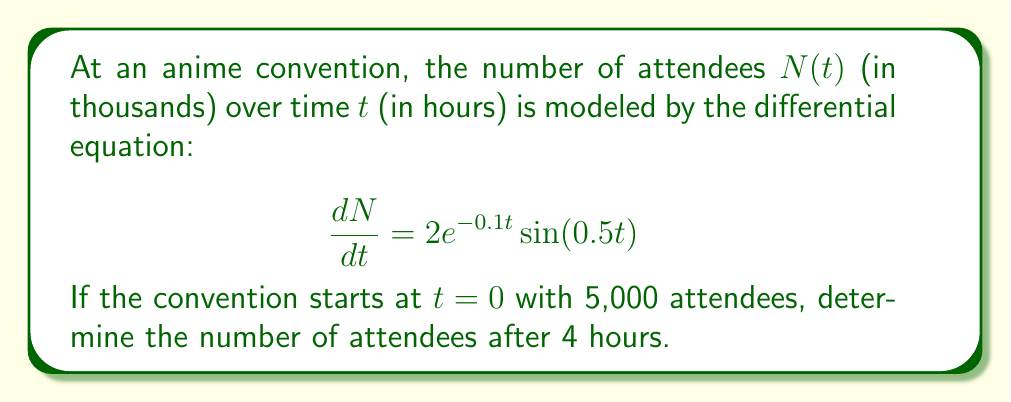Give your solution to this math problem. Let's approach this step-by-step:

1) We're given the differential equation:

   $$\frac{dN}{dt} = 2e^{-0.1t} \sin(0.5t)$$

2) To find the number of attendees at $t=4$, we need to integrate this equation from $t=0$ to $t=4$:

   $$N(4) - N(0) = \int_0^4 2e^{-0.1t} \sin(0.5t) dt$$

3) This integral doesn't have an elementary antiderivative, so we'll need to use numerical integration. We can use the trapezoidal rule with a small step size (let's use 0.1) for a good approximation.

4) Implementing the trapezoidal rule:

   $$\int_0^4 2e^{-0.1t} \sin(0.5t) dt \approx 0.1 \sum_{i=0}^{39} \frac{f(t_i) + f(t_{i+1})}{2}$$

   where $f(t) = 2e^{-0.1t} \sin(0.5t)$ and $t_i = 0.1i$

5) Calculating this sum (which can be done with a calculator or computer):

   $$\int_0^4 2e^{-0.1t} \sin(0.5t) dt \approx 2.7136$$

6) Now we can solve for $N(4)$:

   $$N(4) - N(0) \approx 2.7136$$
   $$N(4) - 5 \approx 2.7136$$
   $$N(4) \approx 7.7136$$

7) Converting back to actual attendees (remember $N$ was in thousands):

   $$N(4) \approx 7,714 \text{ attendees}$$
Answer: After 4 hours, there will be approximately 7,714 attendees at the anime convention. 